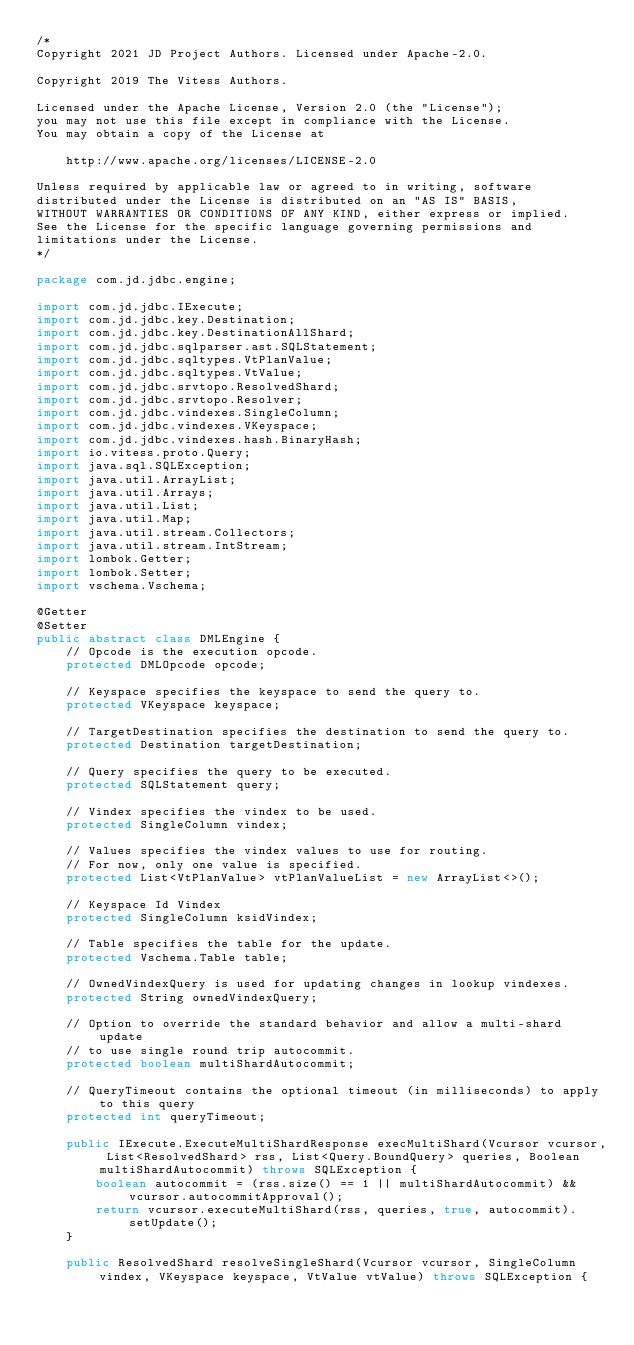Convert code to text. <code><loc_0><loc_0><loc_500><loc_500><_Java_>/*
Copyright 2021 JD Project Authors. Licensed under Apache-2.0.

Copyright 2019 The Vitess Authors.

Licensed under the Apache License, Version 2.0 (the "License");
you may not use this file except in compliance with the License.
You may obtain a copy of the License at

    http://www.apache.org/licenses/LICENSE-2.0

Unless required by applicable law or agreed to in writing, software
distributed under the License is distributed on an "AS IS" BASIS,
WITHOUT WARRANTIES OR CONDITIONS OF ANY KIND, either express or implied.
See the License for the specific language governing permissions and
limitations under the License.
*/

package com.jd.jdbc.engine;

import com.jd.jdbc.IExecute;
import com.jd.jdbc.key.Destination;
import com.jd.jdbc.key.DestinationAllShard;
import com.jd.jdbc.sqlparser.ast.SQLStatement;
import com.jd.jdbc.sqltypes.VtPlanValue;
import com.jd.jdbc.sqltypes.VtValue;
import com.jd.jdbc.srvtopo.ResolvedShard;
import com.jd.jdbc.srvtopo.Resolver;
import com.jd.jdbc.vindexes.SingleColumn;
import com.jd.jdbc.vindexes.VKeyspace;
import com.jd.jdbc.vindexes.hash.BinaryHash;
import io.vitess.proto.Query;
import java.sql.SQLException;
import java.util.ArrayList;
import java.util.Arrays;
import java.util.List;
import java.util.Map;
import java.util.stream.Collectors;
import java.util.stream.IntStream;
import lombok.Getter;
import lombok.Setter;
import vschema.Vschema;

@Getter
@Setter
public abstract class DMLEngine {
    // Opcode is the execution opcode.
    protected DMLOpcode opcode;

    // Keyspace specifies the keyspace to send the query to.
    protected VKeyspace keyspace;

    // TargetDestination specifies the destination to send the query to.
    protected Destination targetDestination;

    // Query specifies the query to be executed.
    protected SQLStatement query;

    // Vindex specifies the vindex to be used.
    protected SingleColumn vindex;

    // Values specifies the vindex values to use for routing.
    // For now, only one value is specified.
    protected List<VtPlanValue> vtPlanValueList = new ArrayList<>();

    // Keyspace Id Vindex
    protected SingleColumn ksidVindex;

    // Table specifies the table for the update.
    protected Vschema.Table table;

    // OwnedVindexQuery is used for updating changes in lookup vindexes.
    protected String ownedVindexQuery;

    // Option to override the standard behavior and allow a multi-shard update
    // to use single round trip autocommit.
    protected boolean multiShardAutocommit;

    // QueryTimeout contains the optional timeout (in milliseconds) to apply to this query
    protected int queryTimeout;

    public IExecute.ExecuteMultiShardResponse execMultiShard(Vcursor vcursor, List<ResolvedShard> rss, List<Query.BoundQuery> queries, Boolean multiShardAutocommit) throws SQLException {
        boolean autocommit = (rss.size() == 1 || multiShardAutocommit) && vcursor.autocommitApproval();
        return vcursor.executeMultiShard(rss, queries, true, autocommit).setUpdate();
    }

    public ResolvedShard resolveSingleShard(Vcursor vcursor, SingleColumn vindex, VKeyspace keyspace, VtValue vtValue) throws SQLException {</code> 